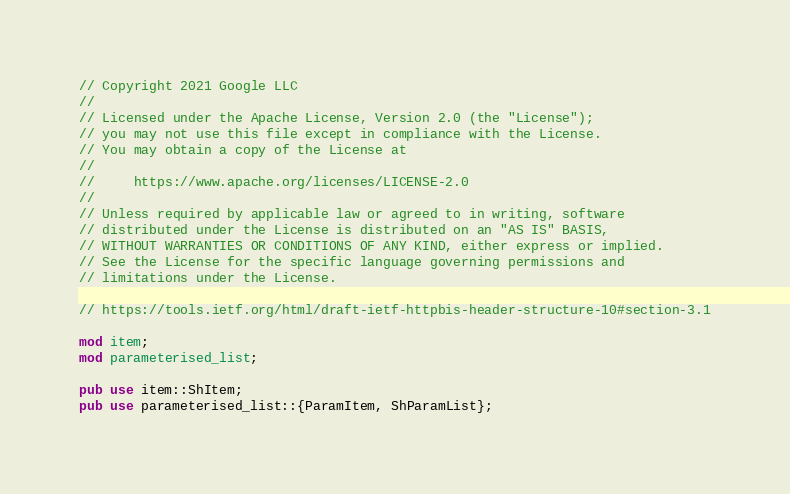<code> <loc_0><loc_0><loc_500><loc_500><_Rust_>// Copyright 2021 Google LLC
//
// Licensed under the Apache License, Version 2.0 (the "License");
// you may not use this file except in compliance with the License.
// You may obtain a copy of the License at
//
//     https://www.apache.org/licenses/LICENSE-2.0
//
// Unless required by applicable law or agreed to in writing, software
// distributed under the License is distributed on an "AS IS" BASIS,
// WITHOUT WARRANTIES OR CONDITIONS OF ANY KIND, either express or implied.
// See the License for the specific language governing permissions and
// limitations under the License.

// https://tools.ietf.org/html/draft-ietf-httpbis-header-structure-10#section-3.1

mod item;
mod parameterised_list;

pub use item::ShItem;
pub use parameterised_list::{ParamItem, ShParamList};
</code> 